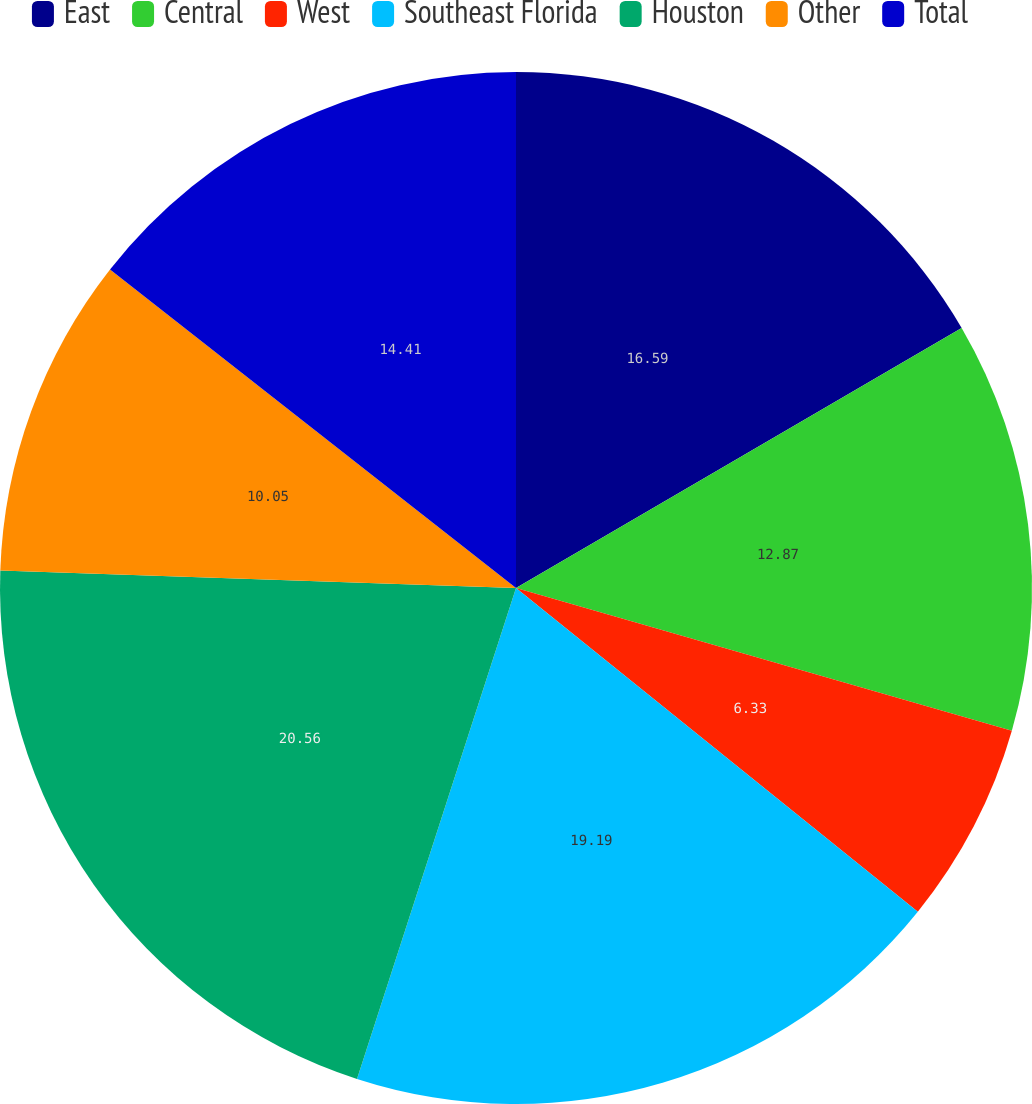Convert chart to OTSL. <chart><loc_0><loc_0><loc_500><loc_500><pie_chart><fcel>East<fcel>Central<fcel>West<fcel>Southeast Florida<fcel>Houston<fcel>Other<fcel>Total<nl><fcel>16.59%<fcel>12.87%<fcel>6.33%<fcel>19.19%<fcel>20.55%<fcel>10.05%<fcel>14.41%<nl></chart> 